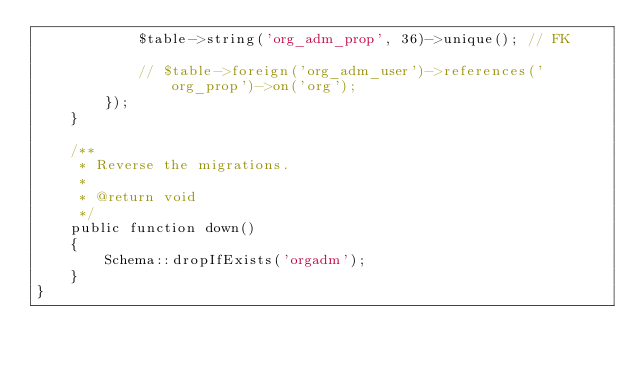<code> <loc_0><loc_0><loc_500><loc_500><_PHP_>            $table->string('org_adm_prop', 36)->unique(); // FK

            // $table->foreign('org_adm_user')->references('org_prop')->on('org');
        });
    }

    /**
     * Reverse the migrations.
     *
     * @return void
     */
    public function down()
    {
        Schema::dropIfExists('orgadm');
    }
}
</code> 